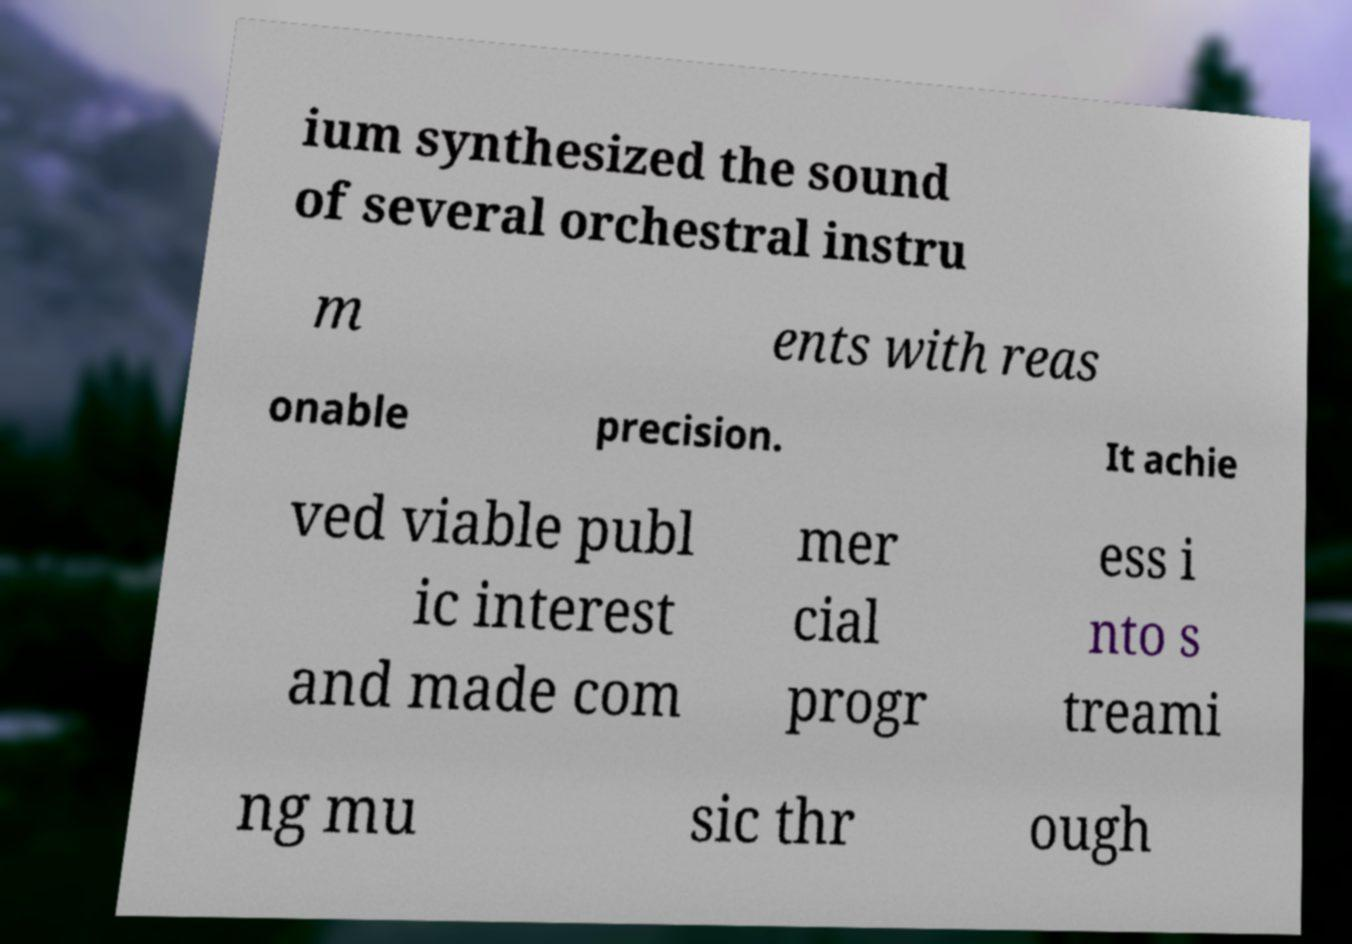Please identify and transcribe the text found in this image. ium synthesized the sound of several orchestral instru m ents with reas onable precision. It achie ved viable publ ic interest and made com mer cial progr ess i nto s treami ng mu sic thr ough 